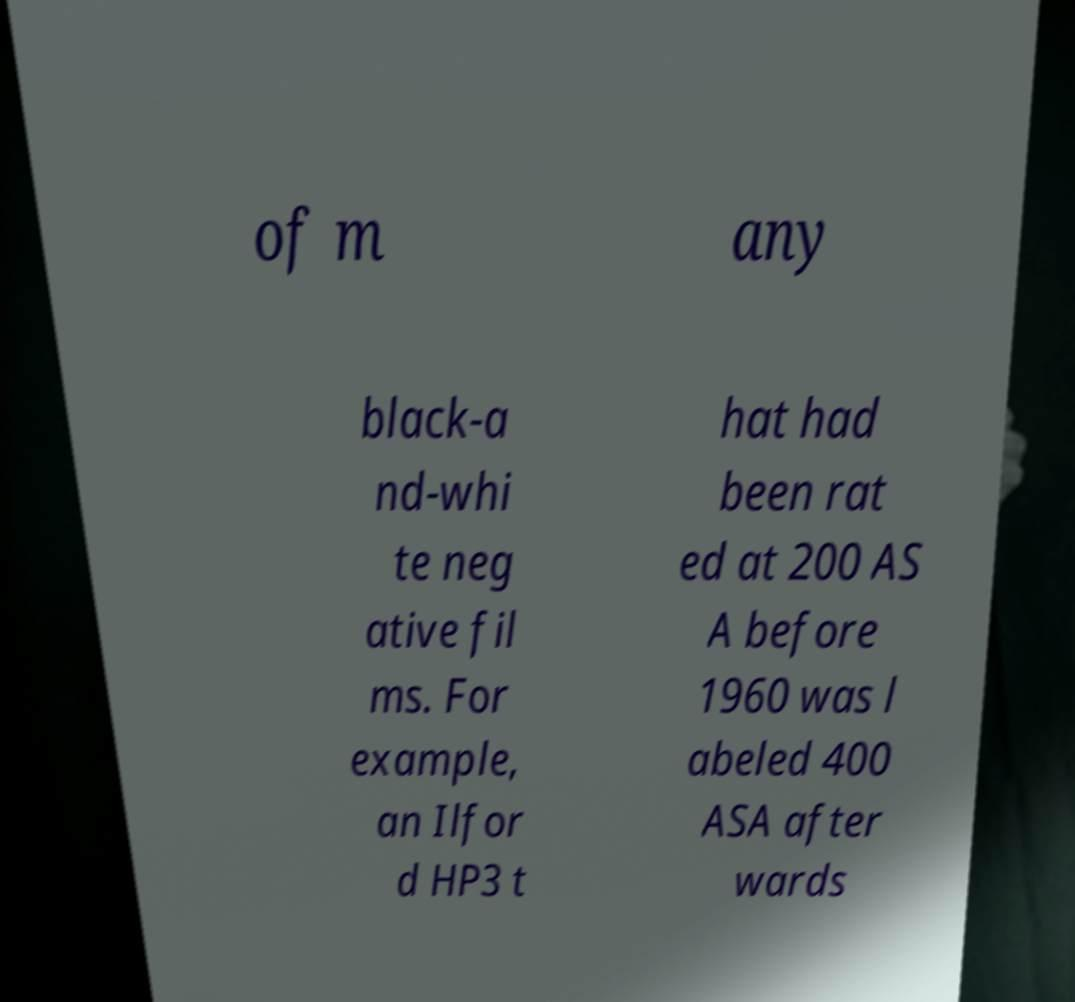Please identify and transcribe the text found in this image. of m any black-a nd-whi te neg ative fil ms. For example, an Ilfor d HP3 t hat had been rat ed at 200 AS A before 1960 was l abeled 400 ASA after wards 